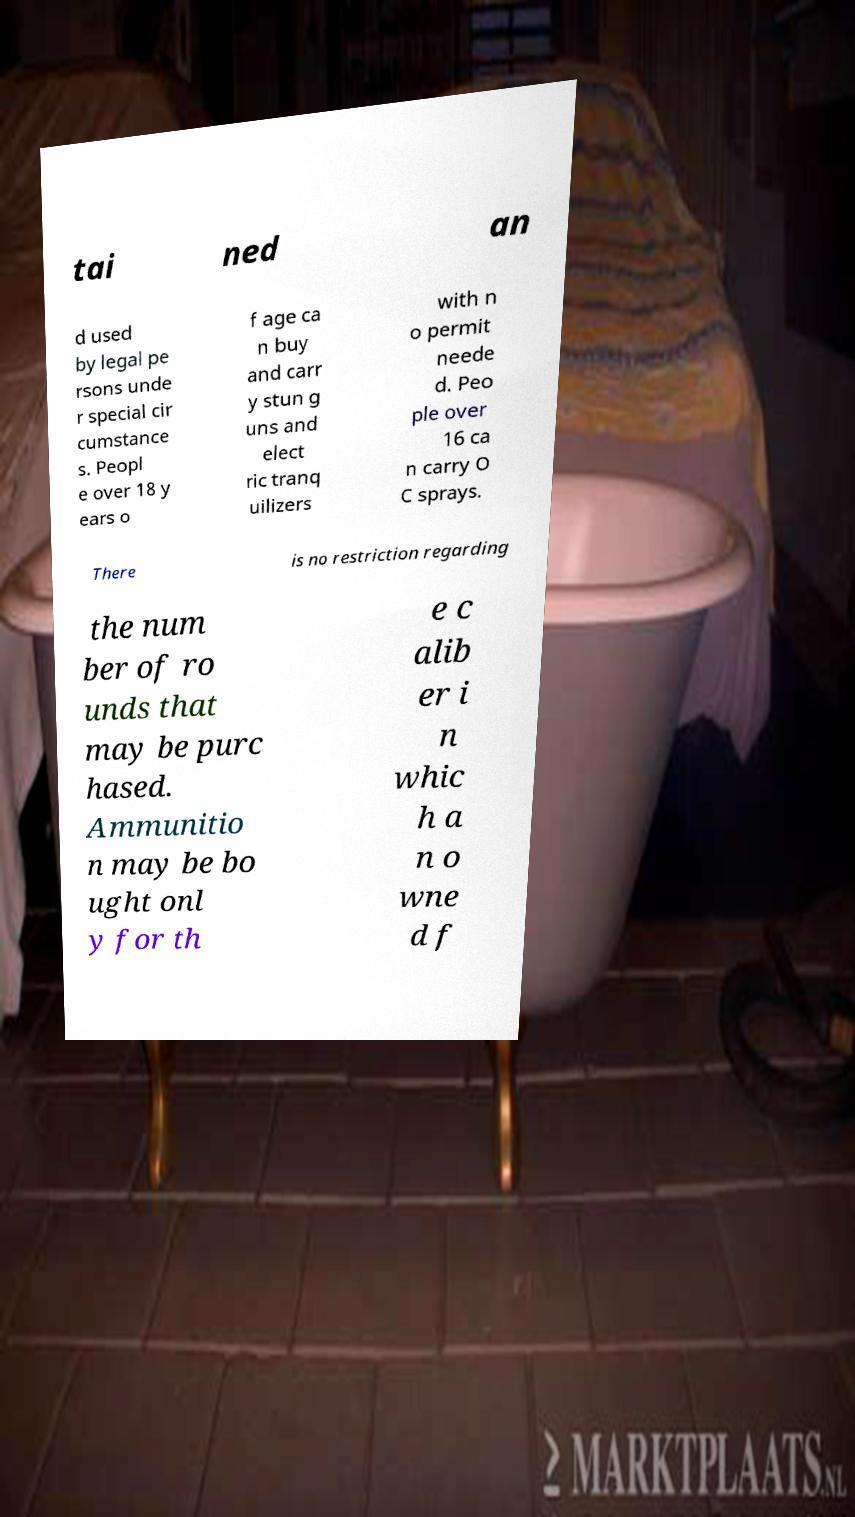I need the written content from this picture converted into text. Can you do that? tai ned an d used by legal pe rsons unde r special cir cumstance s. Peopl e over 18 y ears o f age ca n buy and carr y stun g uns and elect ric tranq uilizers with n o permit neede d. Peo ple over 16 ca n carry O C sprays. There is no restriction regarding the num ber of ro unds that may be purc hased. Ammunitio n may be bo ught onl y for th e c alib er i n whic h a n o wne d f 